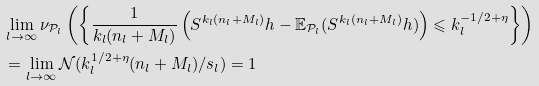<formula> <loc_0><loc_0><loc_500><loc_500>& \lim _ { l \to \infty } \nu _ { \mathcal { P } _ { l } } \left ( \left \{ \frac { 1 } { k _ { l } ( n _ { l } + M _ { l } ) } \left ( S ^ { k _ { l } ( n _ { l } + M _ { l } ) } h - \mathbb { E } _ { \mathcal { P } _ { l } } ( S ^ { k _ { l } ( n _ { l } + M _ { l } ) } h ) \right ) \leqslant k _ { l } ^ { - 1 / 2 + \eta } \right \} \right ) \\ & = \lim _ { l \to \infty } \mathcal { N } ( k _ { l } ^ { 1 / 2 + \eta } ( n _ { l } + M _ { l } ) / s _ { l } ) = 1</formula> 